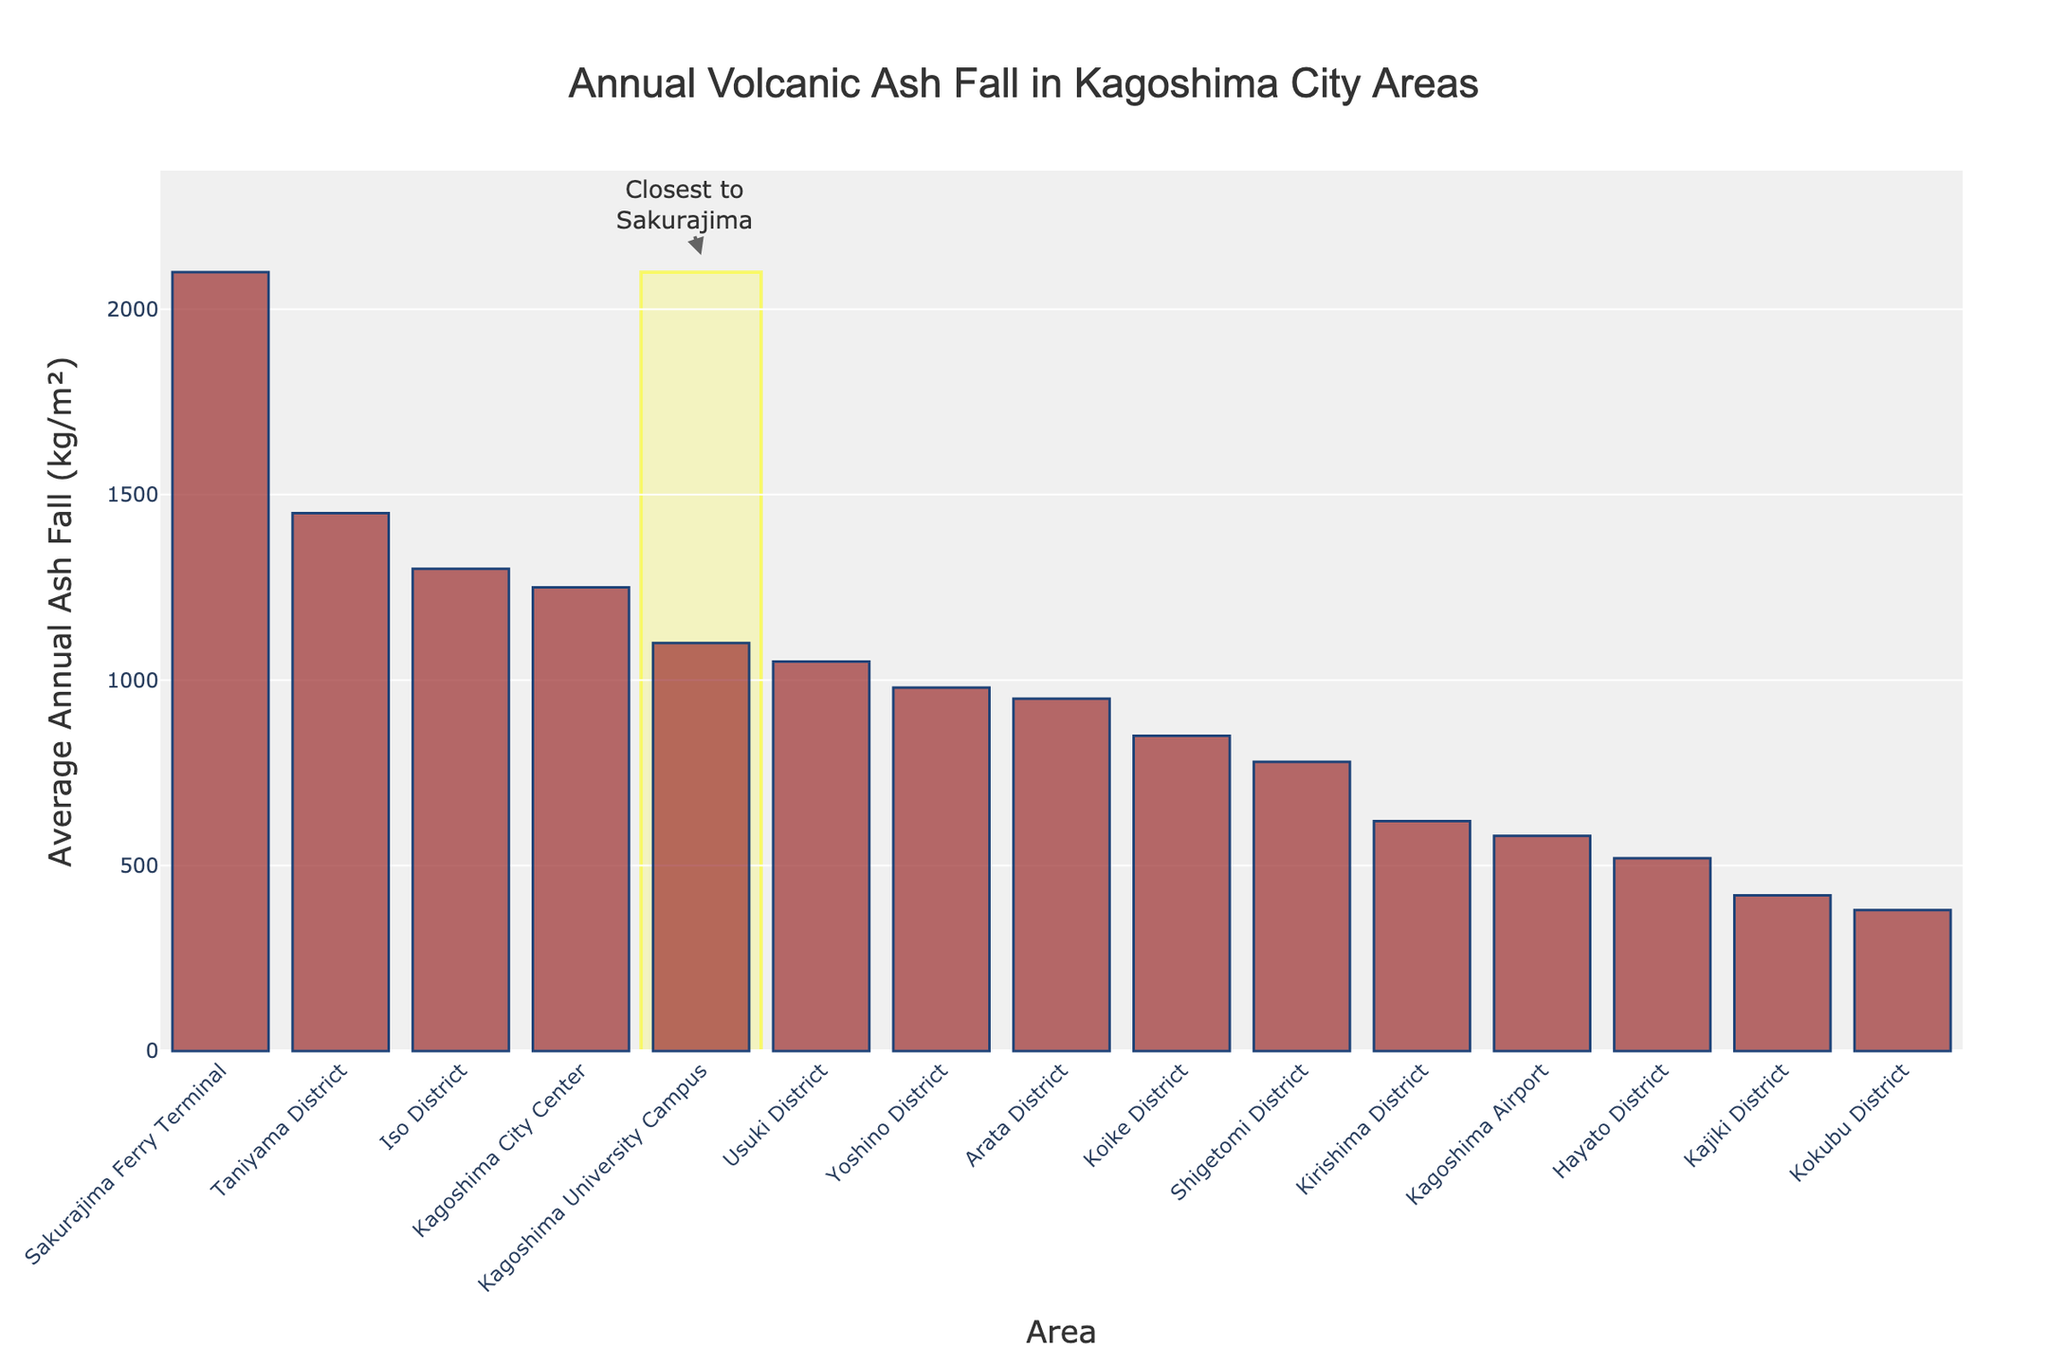Which area has the highest average annual ash fall? The figure shows the average annual ash fall for each area in the Kagoshima City, with the highest bar representing the maximum value. The Sakurajima Ferry Terminal has the highest bar.
Answer: Sakurajima Ferry Terminal Compare the average annual ash fall between Kagoshima City Center and Taniyama District. Which one is higher and by how much? Identify the bars for Kagoshima City Center and Taniyama District. Kagoshima City Center has a value of 1250 kg/m²; Taniyama District has a value of 1450 kg/m². Subtract the smaller value from the larger one: 1450 - 1250 = 200 kg/m².
Answer: Taniyama District is higher by 200 kg/m² What is the sum of the average annual ash fall amounts for Koike District and Kajiki District? Locate the bars for Koike District and Kajiki District. Koike District shows 850 kg/m² and Kajiki District shows 420 kg/m². Add the values: 850 + 420 = 1270 kg/m².
Answer: 1270 kg/m² Which area has the smallest average annual ash fall? The figure shows the average annual ash fall for each area in the Kagoshima City, with the smallest bar representing the minimum value. Kokubu District has the smallest bar.
Answer: Kokubu District How much more is the average annual ash fall at the Kagoshima University Campus compared to the Kirishima District? Identify the bars for Kagoshima University Campus and Kirishima District. Kagoshima University Campus shows 1100 kg/m² and Kirishima District shows 620 kg/m². Subtract the smaller value from the larger one: 1100 - 620 = 480 kg/m².
Answer: 480 kg/m² What is the average ash fall amount of the five areas with the highest values? Identify the top five areas with the highest ash fall values: Sakurajima Ferry Terminal (2100 kg/m²), Taniyama District (1450 kg/m²), Iso District (1300 kg/m²), Kagoshima University Campus (1100 kg/m²), and Kagoshima City Center (1250 kg/m²). Sum these values and divide by 5: (2100 + 1450 + 1300 + 1100 + 1250) / 5 = 7200 / 5 = 1440 kg/m².
Answer: 1440 kg/m² Which area closest to Sakurajima is highlighted in the figure and why? The figure visually highlights the Sakurajima Ferry Terminal with a yellow rectangle. The figure also includes a related annotation that says "Closest to Sakurajima."
Answer: Sakurajima Ferry Terminal Compare the ash fall amounts of Yoshino District and Usuki District and state the ratio of Yoshino to Usuki. Identify the bars for Yoshino District and Usuki District. Yoshino District shows 980 kg/m² and Usuki District shows 1050 kg/m². The ratio is calculated as 980 / 1050, which simplifies approximately to 0.933.
Answer: 0.933 What is the combined average annual ash fall for Shigetomi and Hayato Districts? Locate the bars for Shigetomi District and Hayato District. Shigetomi District has an ash fall amount of 780 kg/m² and Hayato District has 520 kg/m². Add the values: 780 + 520 = 1300 kg/m².
Answer: 1300 kg/m² 